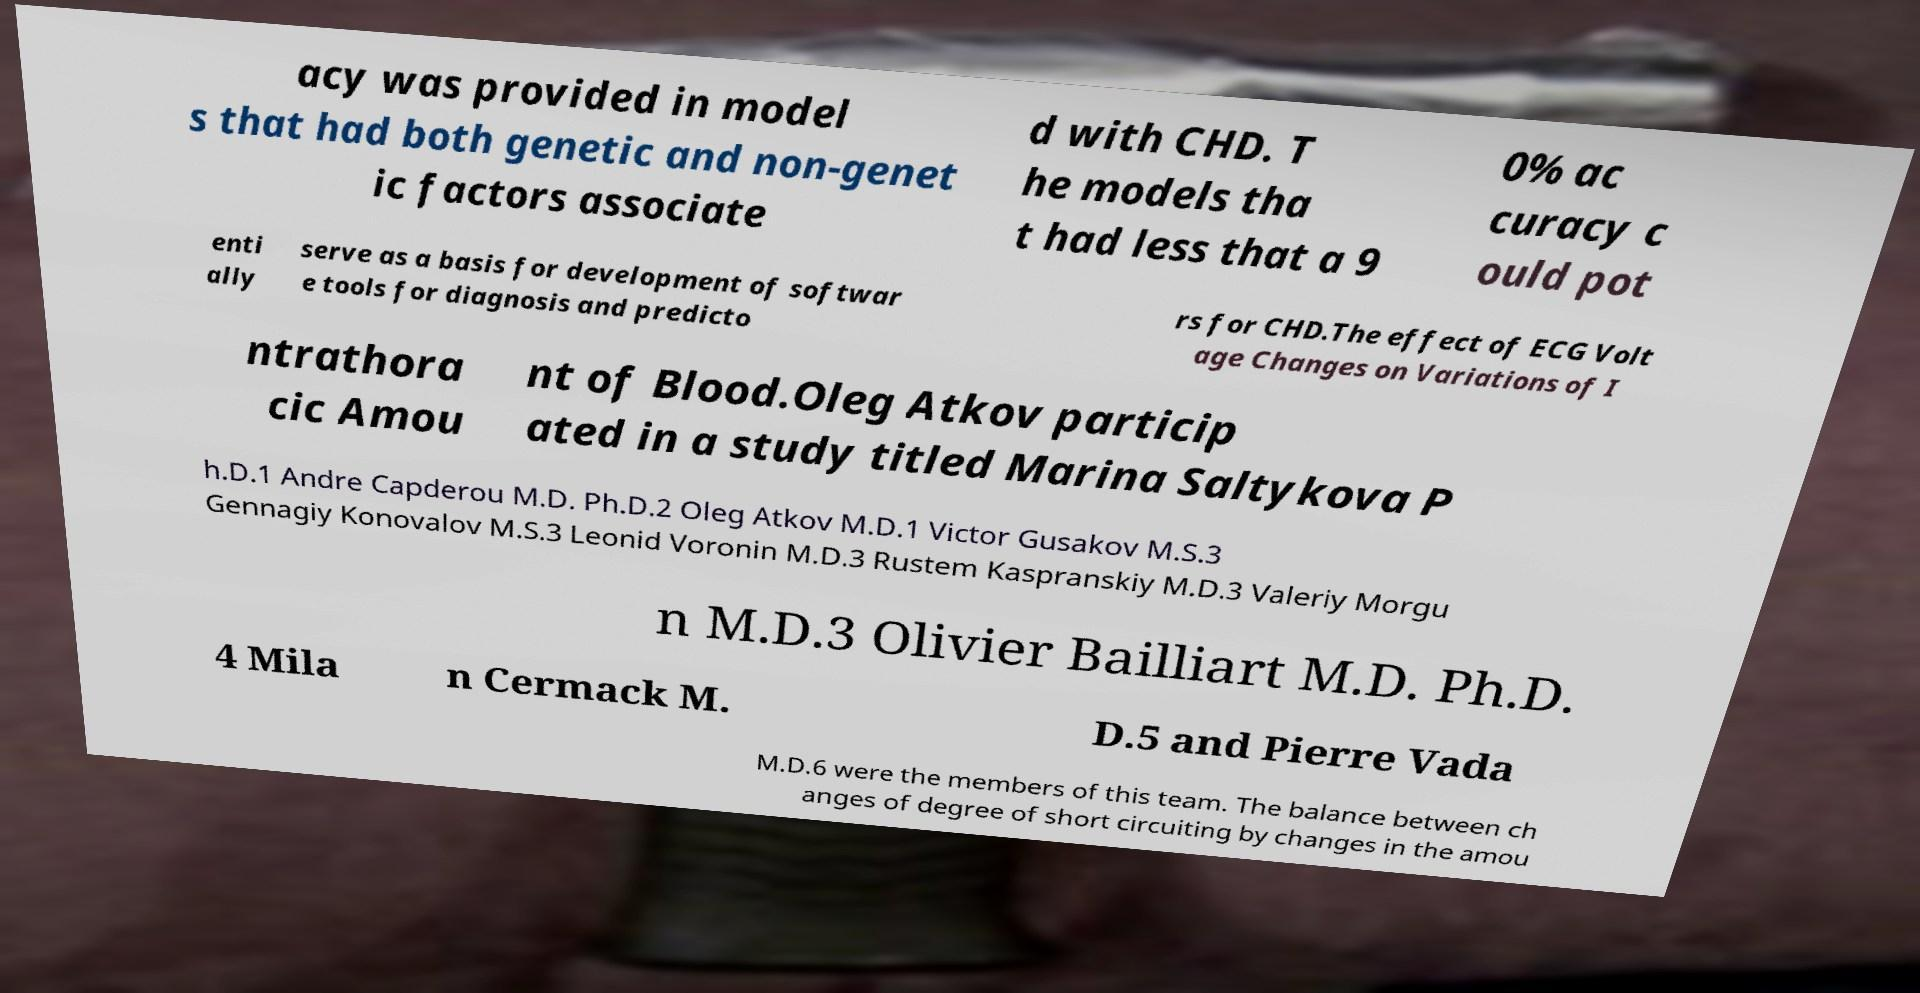Please identify and transcribe the text found in this image. acy was provided in model s that had both genetic and non-genet ic factors associate d with CHD. T he models tha t had less that a 9 0% ac curacy c ould pot enti ally serve as a basis for development of softwar e tools for diagnosis and predicto rs for CHD.The effect of ECG Volt age Changes on Variations of I ntrathora cic Amou nt of Blood.Oleg Atkov particip ated in a study titled Marina Saltykova P h.D.1 Andre Capderou M.D. Ph.D.2 Oleg Atkov M.D.1 Victor Gusakov M.S.3 Gennagiy Konovalov M.S.3 Leonid Voronin M.D.3 Rustem Kaspranskiy M.D.3 Valeriy Morgu n M.D.3 Olivier Bailliart M.D. Ph.D. 4 Mila n Cermack M. D.5 and Pierre Vada M.D.6 were the members of this team. The balance between ch anges of degree of short circuiting by changes in the amou 